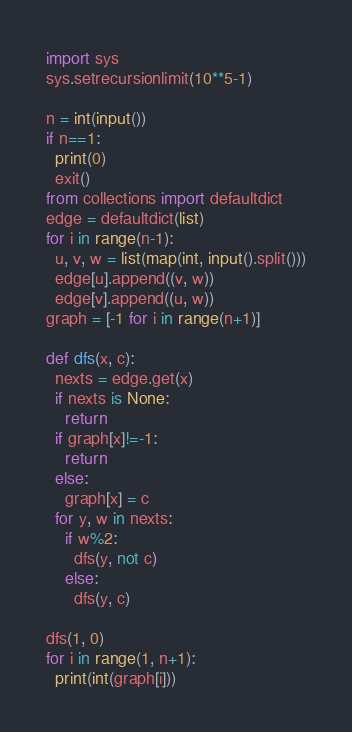<code> <loc_0><loc_0><loc_500><loc_500><_Python_>import sys
sys.setrecursionlimit(10**5-1)

n = int(input())
if n==1:
  print(0)
  exit()
from collections import defaultdict
edge = defaultdict(list)
for i in range(n-1):
  u, v, w = list(map(int, input().split()))
  edge[u].append((v, w))
  edge[v].append((u, w))
graph = [-1 for i in range(n+1)]

def dfs(x, c):
  nexts = edge.get(x)
  if nexts is None:
    return
  if graph[x]!=-1:
    return
  else:
    graph[x] = c
  for y, w in nexts:
    if w%2:
      dfs(y, not c)
    else:
      dfs(y, c)

dfs(1, 0)
for i in range(1, n+1):
  print(int(graph[i]))</code> 